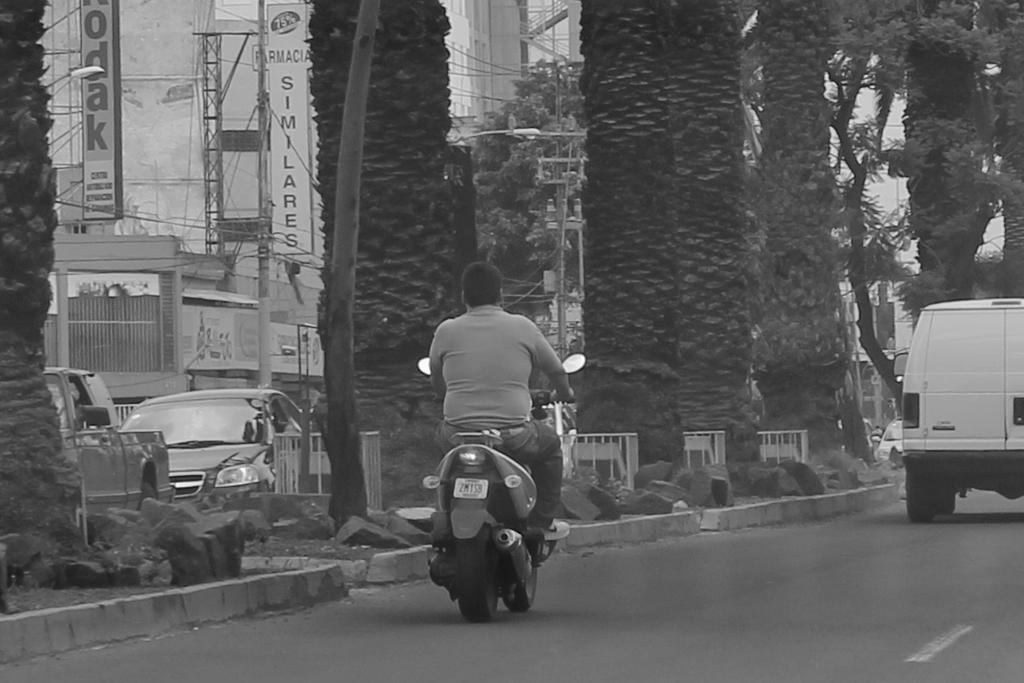Can you describe this image briefly? In this image the person is riding the bike and one vehicle is going on and beside the person there are some trees 